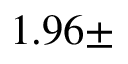Convert formula to latex. <formula><loc_0><loc_0><loc_500><loc_500>1 . 9 6 \pm</formula> 